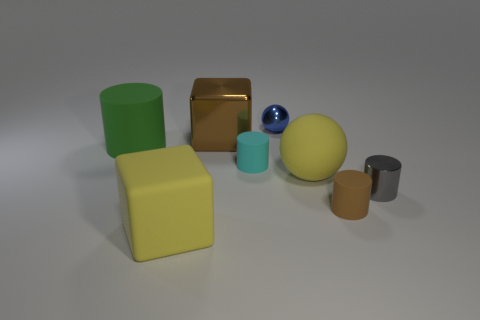Is the number of brown cylinders less than the number of tiny red blocks?
Offer a very short reply. No. There is a matte thing that is both right of the tiny blue metal object and behind the small gray metal thing; what shape is it?
Keep it short and to the point. Sphere. What number of large things are there?
Your answer should be very brief. 4. What material is the big thing in front of the tiny matte cylinder that is right of the ball right of the blue metallic thing?
Your response must be concise. Rubber. What number of metallic cylinders are to the left of the matte cylinder on the left side of the cyan matte cylinder?
Make the answer very short. 0. There is another big object that is the same shape as the gray thing; what is its color?
Your answer should be very brief. Green. Is the material of the large cylinder the same as the brown cylinder?
Your response must be concise. Yes. How many blocks are brown metallic things or green matte things?
Make the answer very short. 1. What size is the green matte cylinder to the left of the large cube in front of the matte cylinder on the left side of the large matte block?
Your answer should be compact. Large. The cyan thing that is the same shape as the small gray metallic thing is what size?
Keep it short and to the point. Small. 